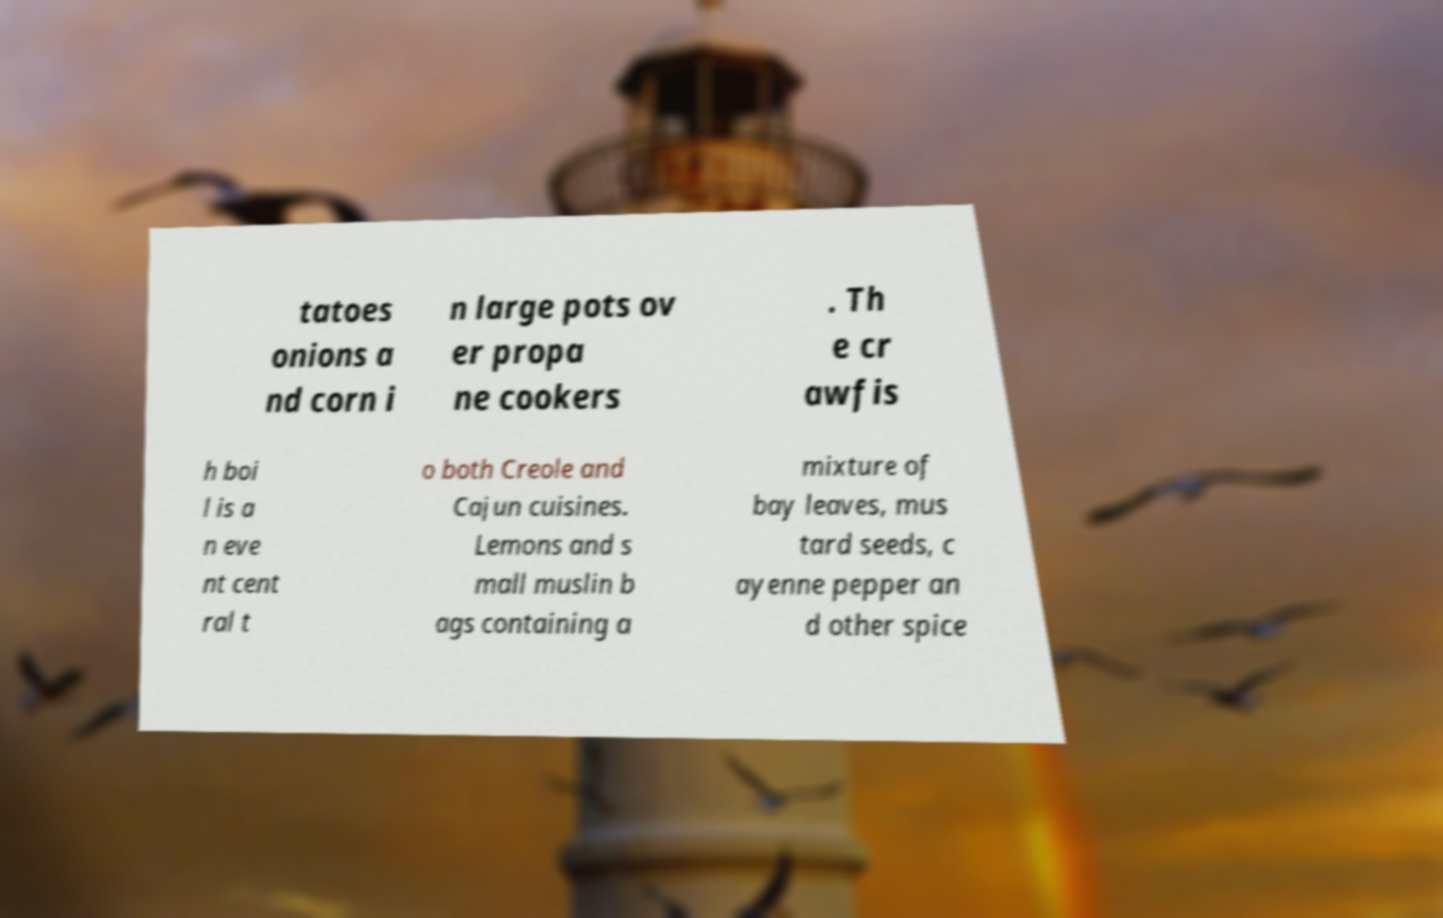Please identify and transcribe the text found in this image. tatoes onions a nd corn i n large pots ov er propa ne cookers . Th e cr awfis h boi l is a n eve nt cent ral t o both Creole and Cajun cuisines. Lemons and s mall muslin b ags containing a mixture of bay leaves, mus tard seeds, c ayenne pepper an d other spice 